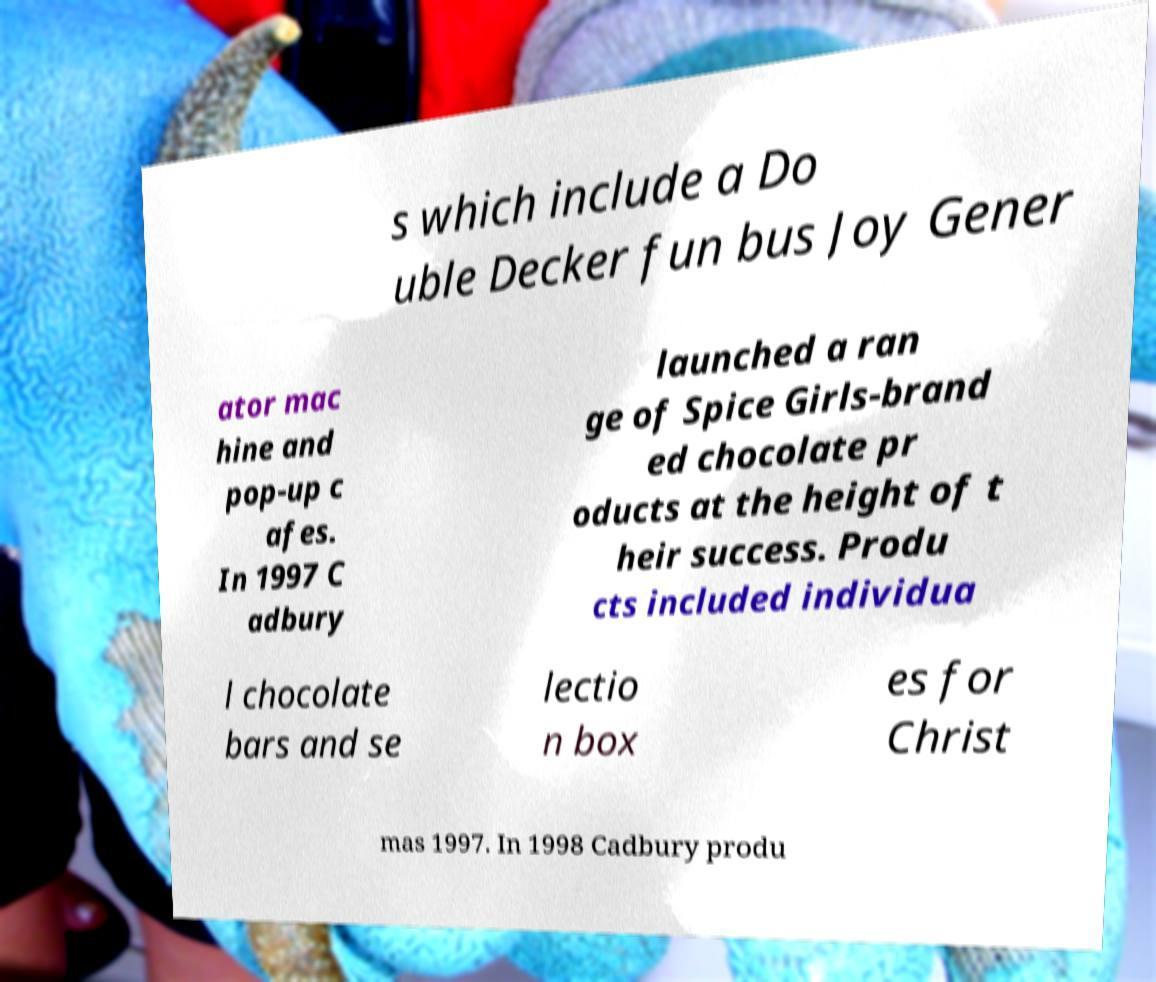Could you assist in decoding the text presented in this image and type it out clearly? s which include a Do uble Decker fun bus Joy Gener ator mac hine and pop-up c afes. In 1997 C adbury launched a ran ge of Spice Girls-brand ed chocolate pr oducts at the height of t heir success. Produ cts included individua l chocolate bars and se lectio n box es for Christ mas 1997. In 1998 Cadbury produ 